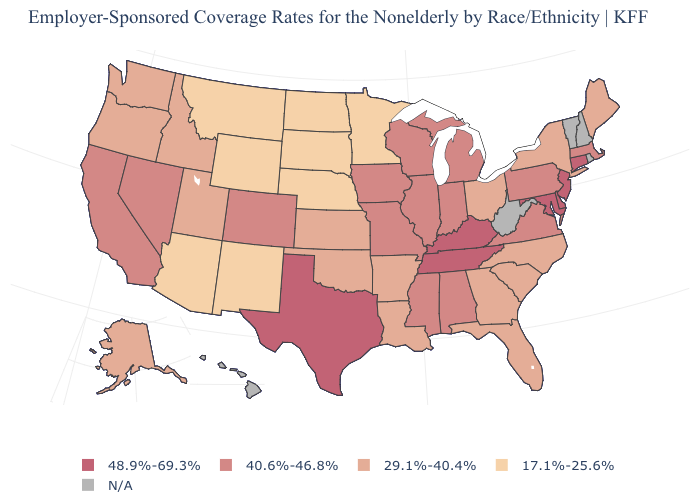Is the legend a continuous bar?
Quick response, please. No. What is the value of South Dakota?
Write a very short answer. 17.1%-25.6%. What is the lowest value in the West?
Be succinct. 17.1%-25.6%. What is the value of Florida?
Keep it brief. 29.1%-40.4%. Is the legend a continuous bar?
Be succinct. No. Name the states that have a value in the range 40.6%-46.8%?
Write a very short answer. Alabama, California, Colorado, Illinois, Indiana, Iowa, Massachusetts, Michigan, Mississippi, Missouri, Nevada, Pennsylvania, Virginia, Wisconsin. Does the map have missing data?
Concise answer only. Yes. What is the highest value in the MidWest ?
Answer briefly. 40.6%-46.8%. Which states have the lowest value in the USA?
Give a very brief answer. Arizona, Minnesota, Montana, Nebraska, New Mexico, North Dakota, South Dakota, Wyoming. Name the states that have a value in the range 40.6%-46.8%?
Quick response, please. Alabama, California, Colorado, Illinois, Indiana, Iowa, Massachusetts, Michigan, Mississippi, Missouri, Nevada, Pennsylvania, Virginia, Wisconsin. What is the value of Kansas?
Answer briefly. 29.1%-40.4%. Which states have the lowest value in the USA?
Quick response, please. Arizona, Minnesota, Montana, Nebraska, New Mexico, North Dakota, South Dakota, Wyoming. Name the states that have a value in the range N/A?
Answer briefly. Hawaii, New Hampshire, Rhode Island, Vermont, West Virginia. Name the states that have a value in the range 29.1%-40.4%?
Keep it brief. Alaska, Arkansas, Florida, Georgia, Idaho, Kansas, Louisiana, Maine, New York, North Carolina, Ohio, Oklahoma, Oregon, South Carolina, Utah, Washington. Name the states that have a value in the range 17.1%-25.6%?
Short answer required. Arizona, Minnesota, Montana, Nebraska, New Mexico, North Dakota, South Dakota, Wyoming. 